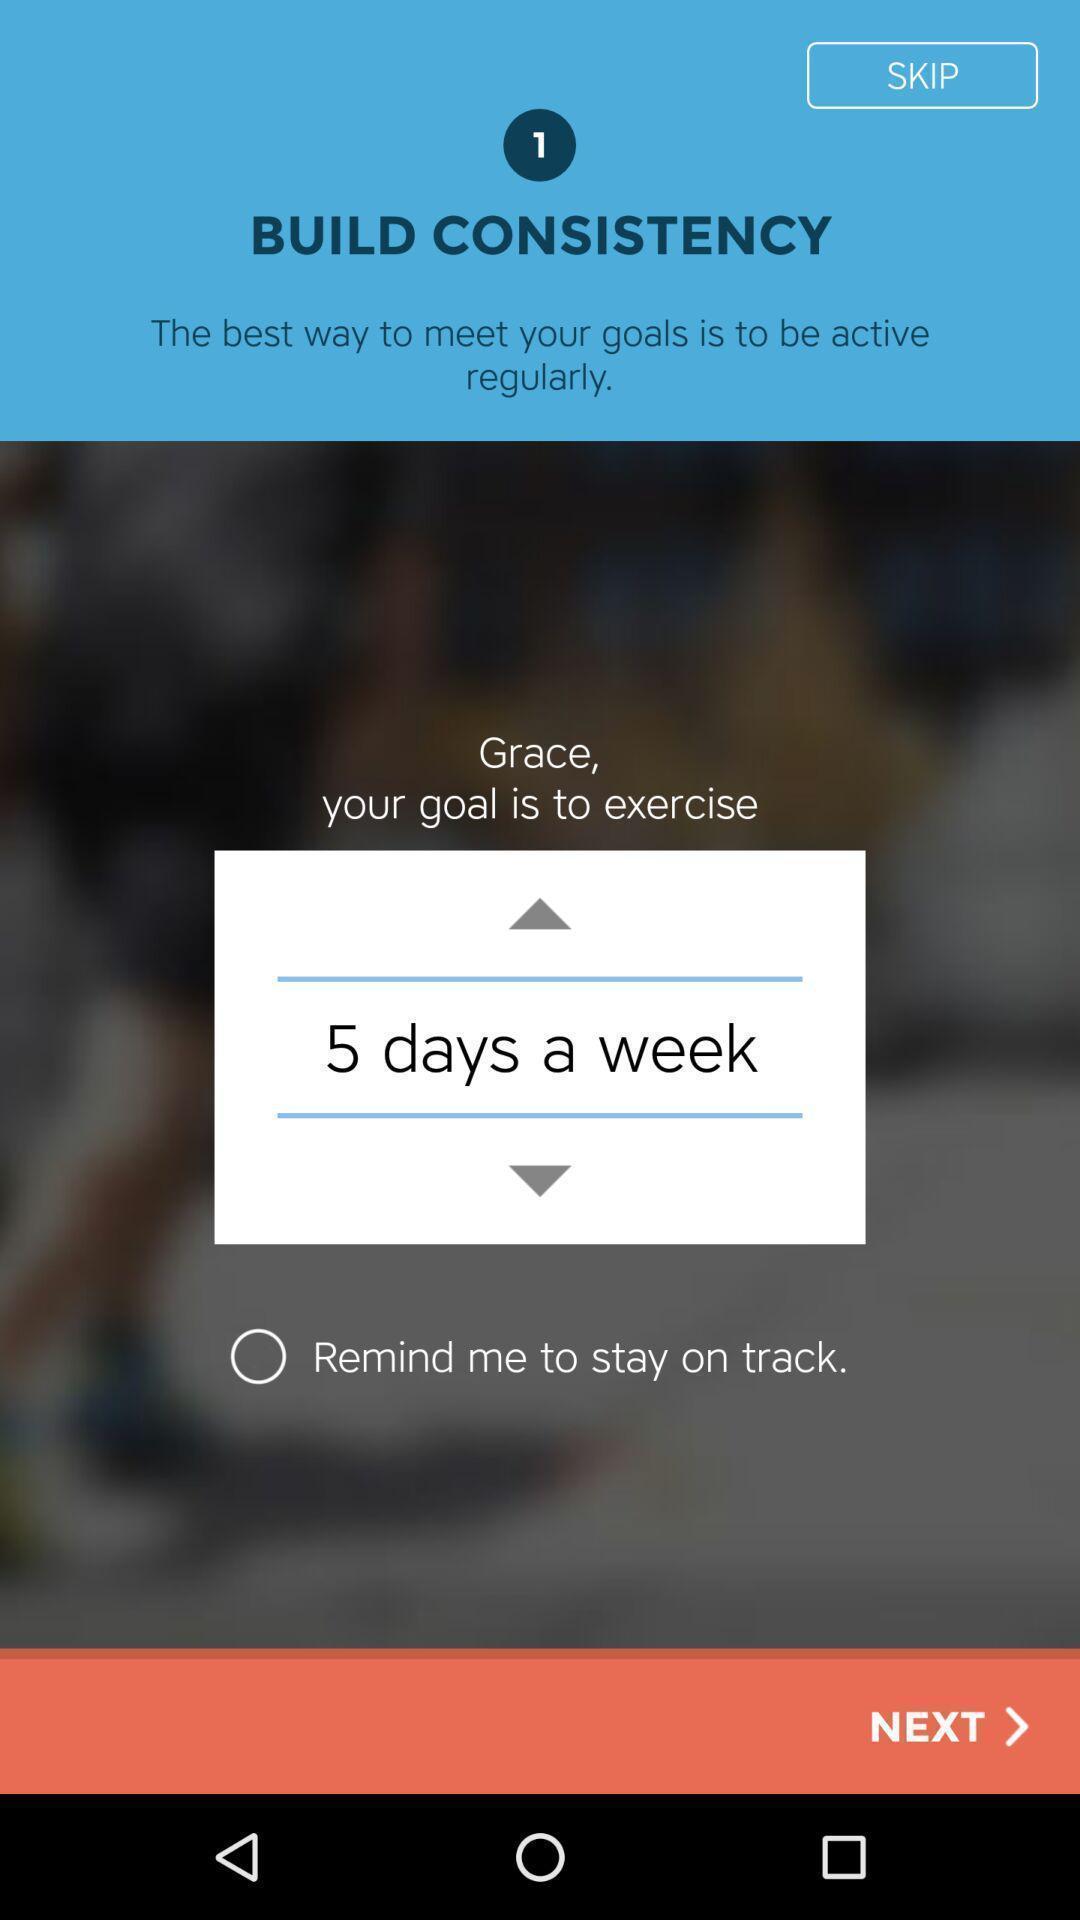Give me a summary of this screen capture. Screen displaying features information of a fitness application. 